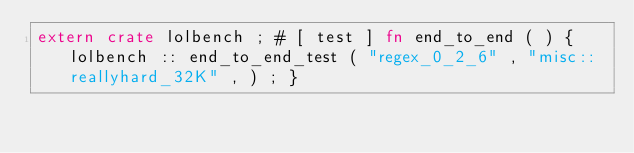Convert code to text. <code><loc_0><loc_0><loc_500><loc_500><_Rust_>extern crate lolbench ; # [ test ] fn end_to_end ( ) { lolbench :: end_to_end_test ( "regex_0_2_6" , "misc::reallyhard_32K" , ) ; }</code> 